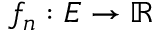Convert formula to latex. <formula><loc_0><loc_0><loc_500><loc_500>f _ { n } \colon E \to \mathbb { R }</formula> 